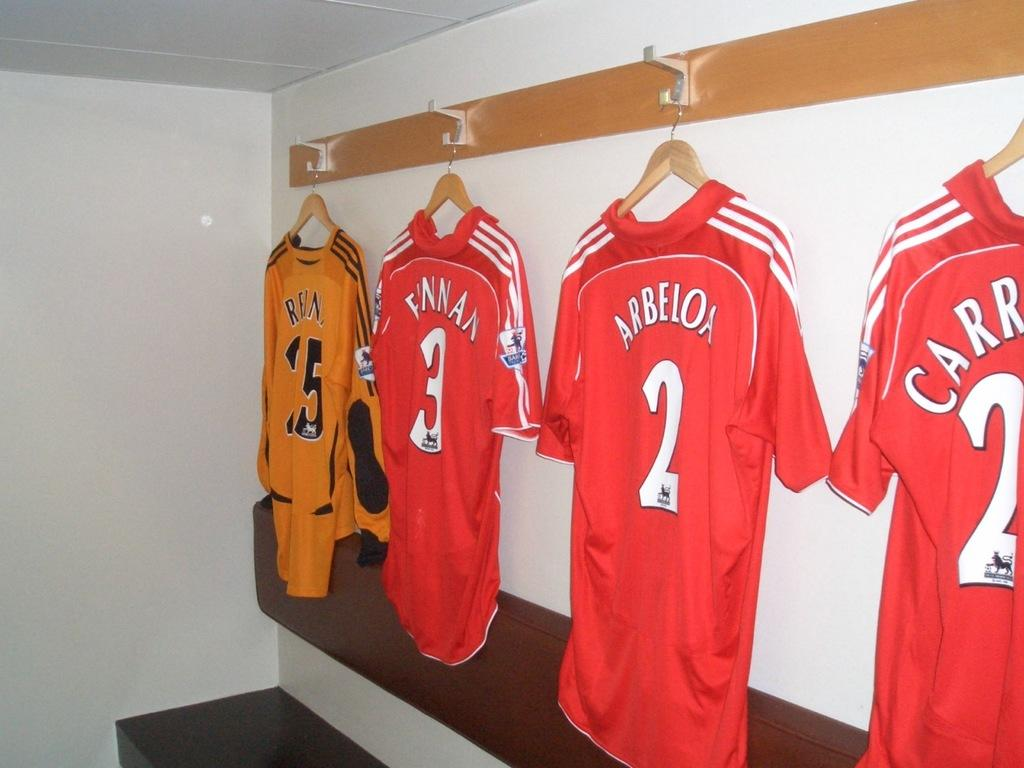<image>
Share a concise interpretation of the image provided. Jerseys are hung up in a locker room and one is for Arbeloa player number 2. 